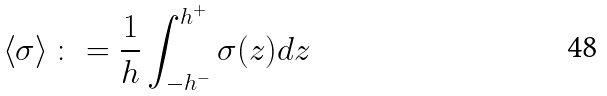Convert formula to latex. <formula><loc_0><loc_0><loc_500><loc_500>\left < \sigma \right > \colon = \frac { 1 } { h } \int ^ { h ^ { + } } _ { - h ^ { - } } \sigma ( z ) d z</formula> 